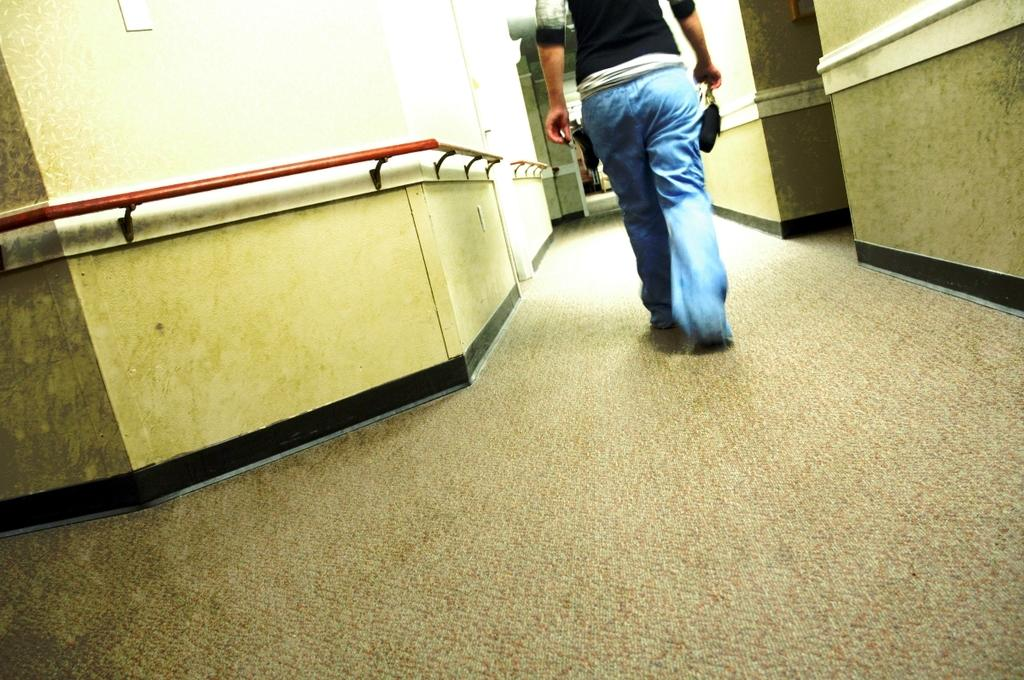What is the main subject of the image? There is a person walking in the image. What is the person walking on? The person is walking on a path. What can be seen on the left side of the person? There is a wall with rods on the left side of the person. How many babies are sitting on the cake in the image? There is no cake or babies present in the image. What type of recess is visible in the image? There is no recess present in the image. 